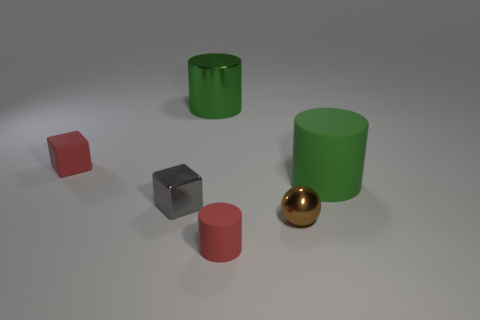How many objects are there and can you describe their shapes? There are five objects in the image, including a small red cube, a small red cylinder, a large green cylinder, a gray cube, and a shiny golden sphere. 